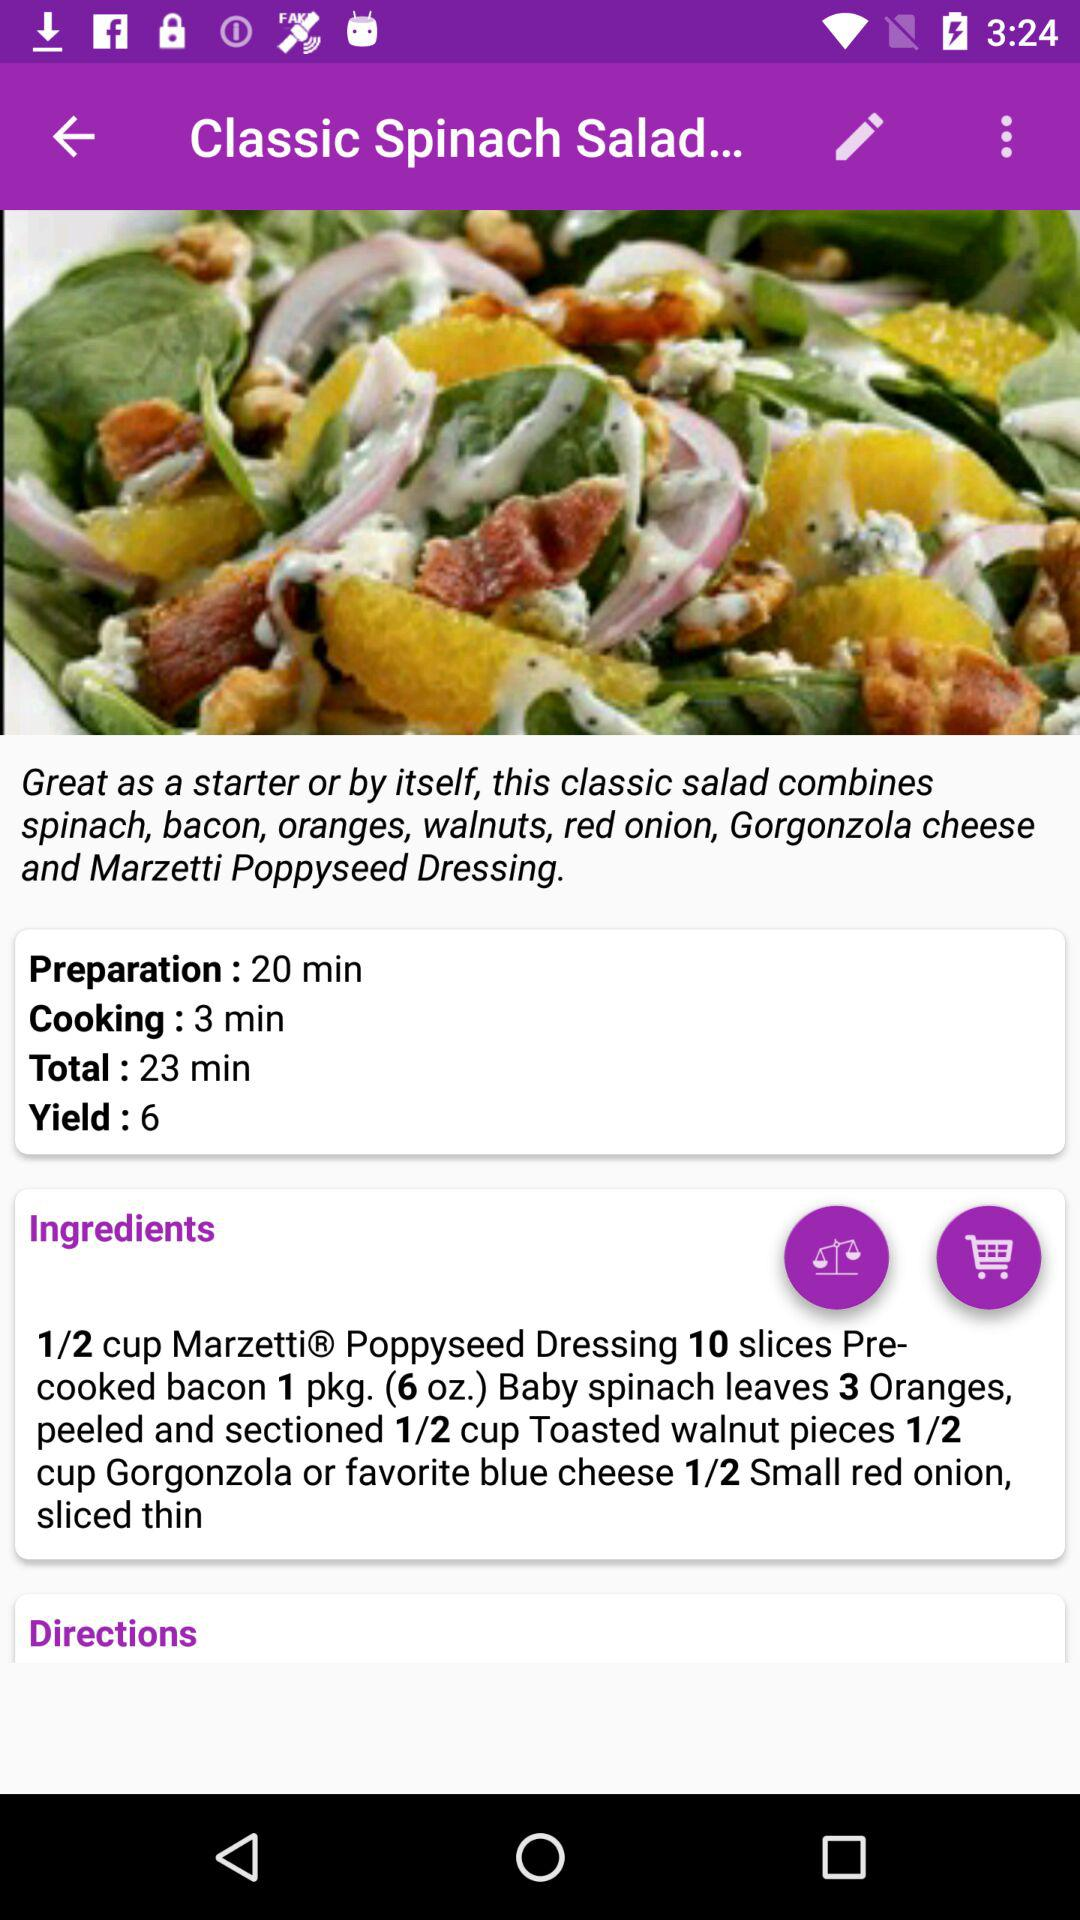How long does it take to make the dish? It takes 23 minutes to make the dish. 